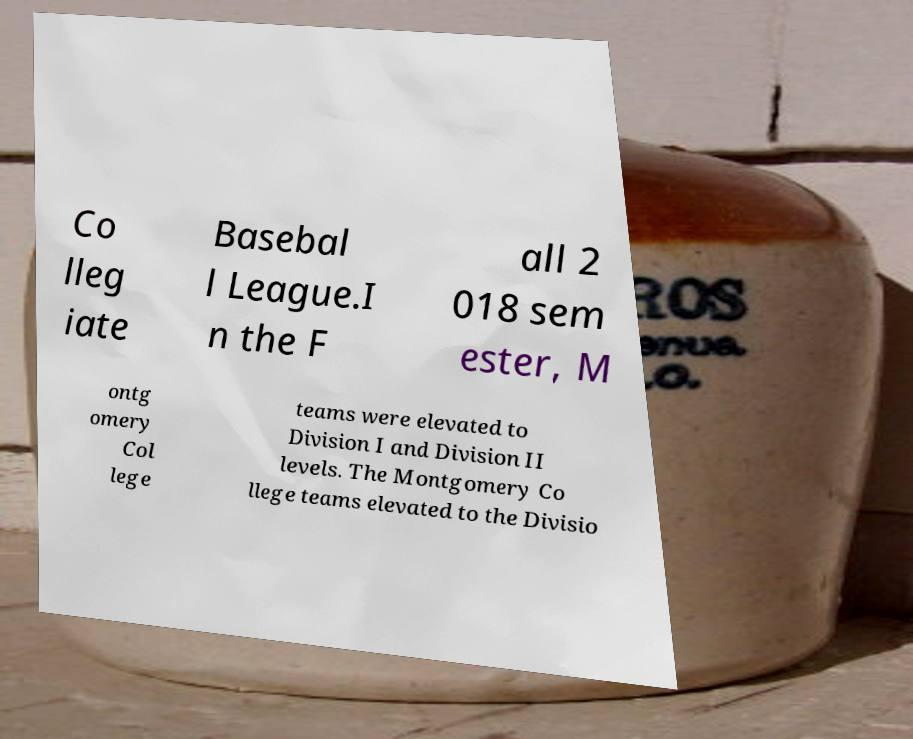Can you read and provide the text displayed in the image?This photo seems to have some interesting text. Can you extract and type it out for me? Co lleg iate Basebal l League.I n the F all 2 018 sem ester, M ontg omery Col lege teams were elevated to Division I and Division II levels. The Montgomery Co llege teams elevated to the Divisio 